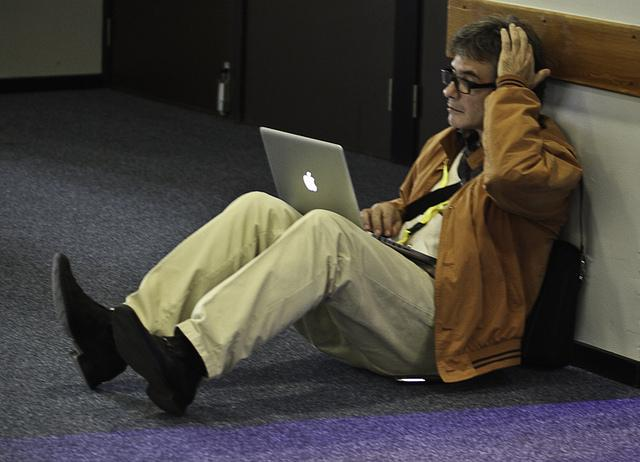Why is this man sitting down? Please explain your reasoning. to work. The man is working. 